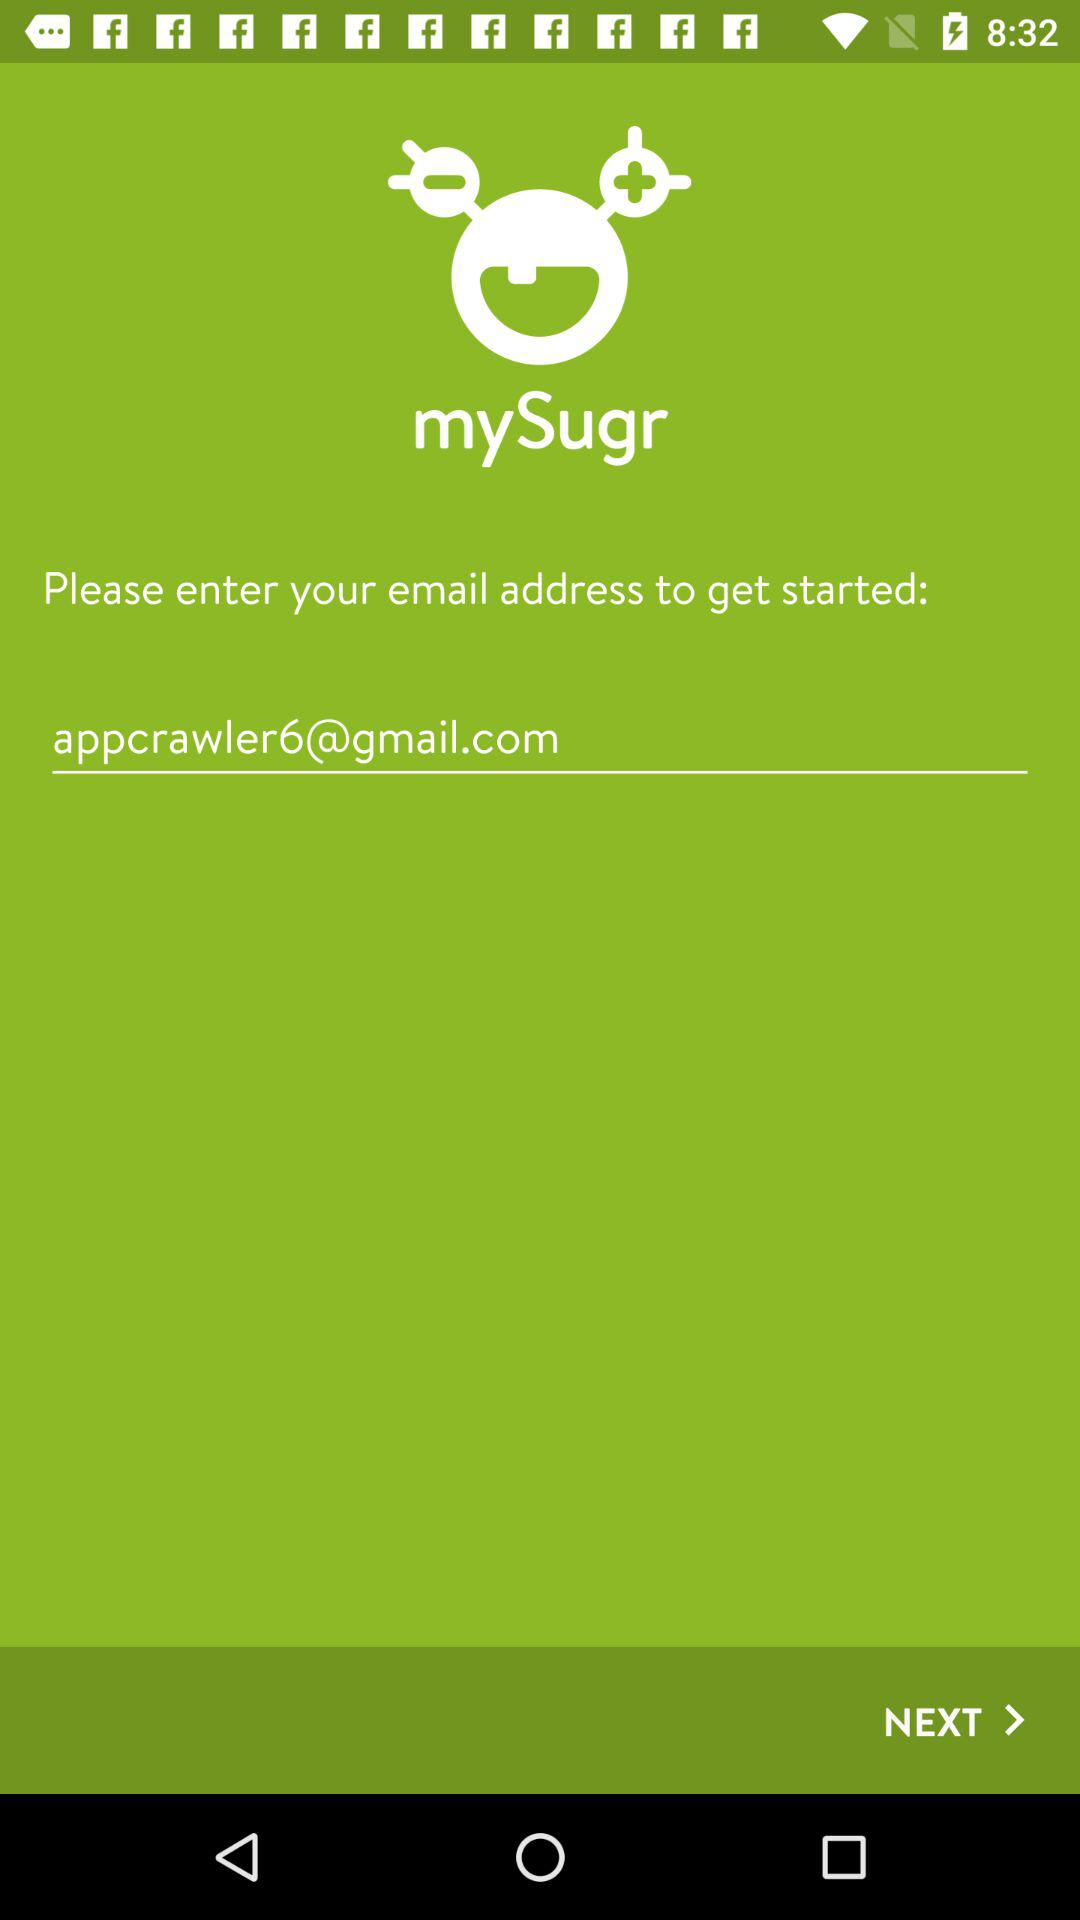What is the name of the application? The name of the application is "mySugr". 